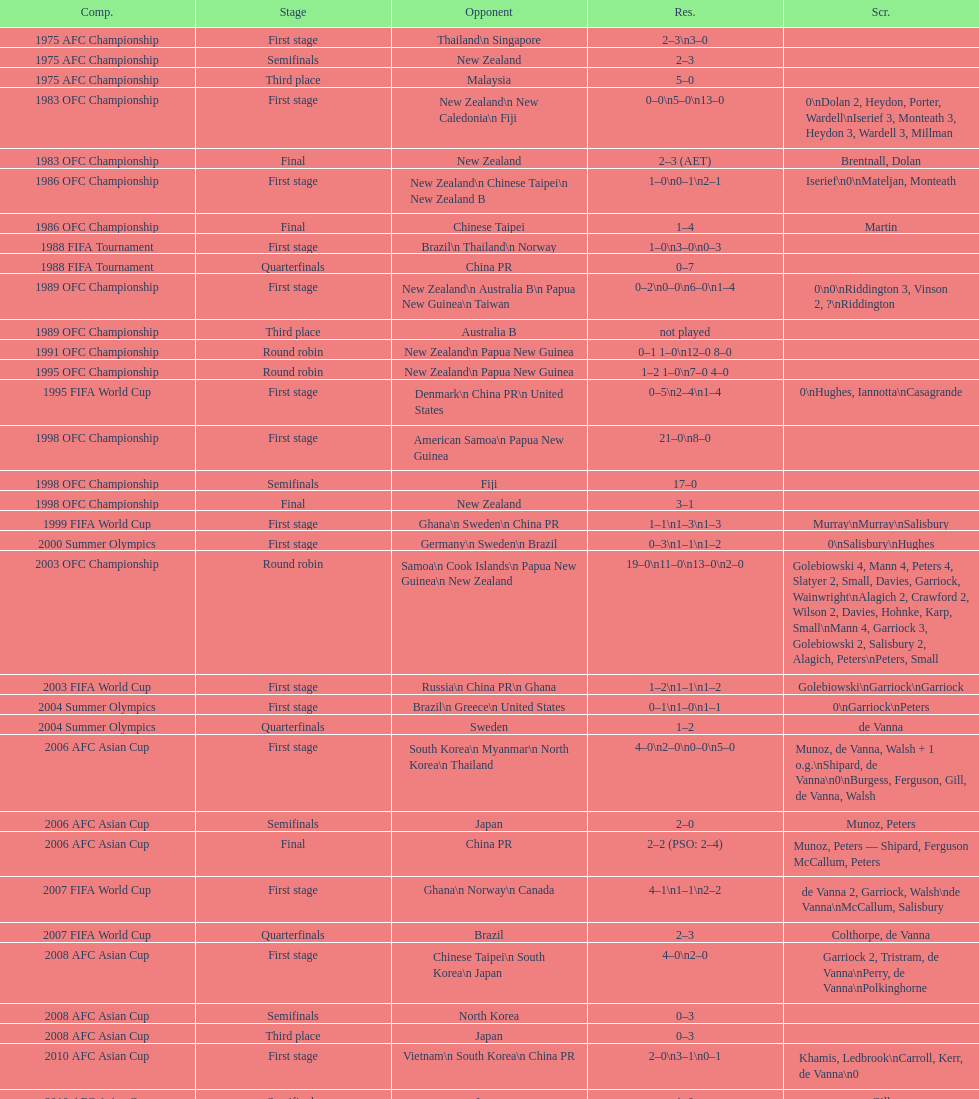Who scored better in the 1995 fifa world cup denmark or the united states? United States. 